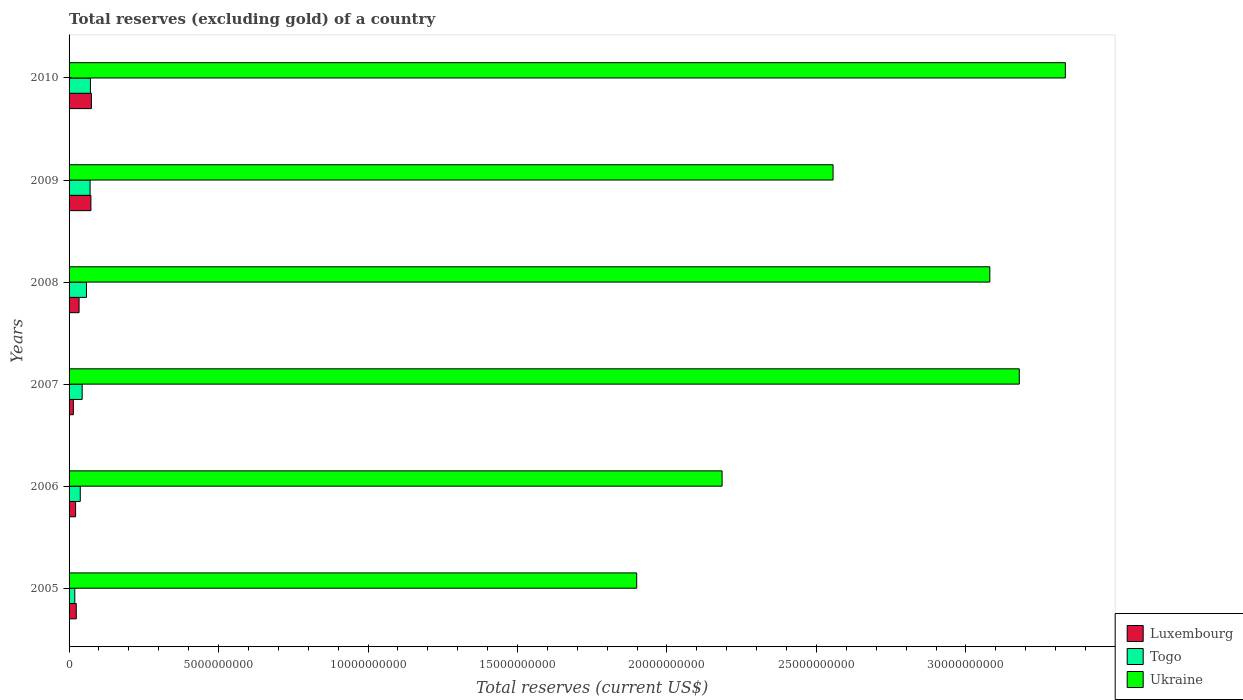How many groups of bars are there?
Ensure brevity in your answer.  6. Are the number of bars per tick equal to the number of legend labels?
Provide a short and direct response. Yes. Are the number of bars on each tick of the Y-axis equal?
Give a very brief answer. Yes. How many bars are there on the 3rd tick from the bottom?
Provide a short and direct response. 3. What is the total reserves (excluding gold) in Togo in 2007?
Offer a very short reply. 4.38e+08. Across all years, what is the maximum total reserves (excluding gold) in Luxembourg?
Give a very brief answer. 7.47e+08. Across all years, what is the minimum total reserves (excluding gold) in Luxembourg?
Keep it short and to the point. 1.44e+08. What is the total total reserves (excluding gold) in Ukraine in the graph?
Your answer should be very brief. 1.62e+11. What is the difference between the total reserves (excluding gold) in Ukraine in 2005 and that in 2010?
Ensure brevity in your answer.  -1.43e+1. What is the difference between the total reserves (excluding gold) in Ukraine in 2009 and the total reserves (excluding gold) in Luxembourg in 2007?
Keep it short and to the point. 2.54e+1. What is the average total reserves (excluding gold) in Ukraine per year?
Your response must be concise. 2.71e+1. In the year 2009, what is the difference between the total reserves (excluding gold) in Luxembourg and total reserves (excluding gold) in Togo?
Keep it short and to the point. 2.74e+07. What is the ratio of the total reserves (excluding gold) in Togo in 2005 to that in 2007?
Provide a succinct answer. 0.44. What is the difference between the highest and the second highest total reserves (excluding gold) in Ukraine?
Your response must be concise. 1.54e+09. What is the difference between the highest and the lowest total reserves (excluding gold) in Ukraine?
Keep it short and to the point. 1.43e+1. In how many years, is the total reserves (excluding gold) in Togo greater than the average total reserves (excluding gold) in Togo taken over all years?
Offer a very short reply. 3. Is the sum of the total reserves (excluding gold) in Togo in 2008 and 2009 greater than the maximum total reserves (excluding gold) in Luxembourg across all years?
Ensure brevity in your answer.  Yes. What does the 2nd bar from the top in 2010 represents?
Provide a short and direct response. Togo. What does the 3rd bar from the bottom in 2009 represents?
Make the answer very short. Ukraine. How many bars are there?
Make the answer very short. 18. What is the difference between two consecutive major ticks on the X-axis?
Provide a short and direct response. 5.00e+09. Are the values on the major ticks of X-axis written in scientific E-notation?
Your response must be concise. No. Does the graph contain any zero values?
Provide a short and direct response. No. How are the legend labels stacked?
Give a very brief answer. Vertical. What is the title of the graph?
Your answer should be compact. Total reserves (excluding gold) of a country. What is the label or title of the X-axis?
Provide a succinct answer. Total reserves (current US$). What is the Total reserves (current US$) of Luxembourg in 2005?
Keep it short and to the point. 2.41e+08. What is the Total reserves (current US$) of Togo in 2005?
Keep it short and to the point. 1.92e+08. What is the Total reserves (current US$) in Ukraine in 2005?
Ensure brevity in your answer.  1.90e+1. What is the Total reserves (current US$) in Luxembourg in 2006?
Keep it short and to the point. 2.18e+08. What is the Total reserves (current US$) of Togo in 2006?
Ensure brevity in your answer.  3.75e+08. What is the Total reserves (current US$) of Ukraine in 2006?
Give a very brief answer. 2.18e+1. What is the Total reserves (current US$) of Luxembourg in 2007?
Provide a succinct answer. 1.44e+08. What is the Total reserves (current US$) of Togo in 2007?
Your answer should be very brief. 4.38e+08. What is the Total reserves (current US$) in Ukraine in 2007?
Make the answer very short. 3.18e+1. What is the Total reserves (current US$) in Luxembourg in 2008?
Your answer should be compact. 3.35e+08. What is the Total reserves (current US$) of Togo in 2008?
Your response must be concise. 5.82e+08. What is the Total reserves (current US$) of Ukraine in 2008?
Keep it short and to the point. 3.08e+1. What is the Total reserves (current US$) of Luxembourg in 2009?
Give a very brief answer. 7.31e+08. What is the Total reserves (current US$) in Togo in 2009?
Offer a very short reply. 7.03e+08. What is the Total reserves (current US$) of Ukraine in 2009?
Ensure brevity in your answer.  2.56e+1. What is the Total reserves (current US$) of Luxembourg in 2010?
Your answer should be compact. 7.47e+08. What is the Total reserves (current US$) of Togo in 2010?
Ensure brevity in your answer.  7.15e+08. What is the Total reserves (current US$) of Ukraine in 2010?
Give a very brief answer. 3.33e+1. Across all years, what is the maximum Total reserves (current US$) of Luxembourg?
Provide a short and direct response. 7.47e+08. Across all years, what is the maximum Total reserves (current US$) of Togo?
Your answer should be very brief. 7.15e+08. Across all years, what is the maximum Total reserves (current US$) of Ukraine?
Keep it short and to the point. 3.33e+1. Across all years, what is the minimum Total reserves (current US$) of Luxembourg?
Your answer should be very brief. 1.44e+08. Across all years, what is the minimum Total reserves (current US$) in Togo?
Make the answer very short. 1.92e+08. Across all years, what is the minimum Total reserves (current US$) of Ukraine?
Provide a succinct answer. 1.90e+1. What is the total Total reserves (current US$) of Luxembourg in the graph?
Offer a terse response. 2.41e+09. What is the total Total reserves (current US$) in Togo in the graph?
Ensure brevity in your answer.  3.00e+09. What is the total Total reserves (current US$) in Ukraine in the graph?
Ensure brevity in your answer.  1.62e+11. What is the difference between the Total reserves (current US$) of Luxembourg in 2005 and that in 2006?
Ensure brevity in your answer.  2.30e+07. What is the difference between the Total reserves (current US$) of Togo in 2005 and that in 2006?
Your answer should be compact. -1.83e+08. What is the difference between the Total reserves (current US$) in Ukraine in 2005 and that in 2006?
Offer a terse response. -2.86e+09. What is the difference between the Total reserves (current US$) of Luxembourg in 2005 and that in 2007?
Your answer should be compact. 9.75e+07. What is the difference between the Total reserves (current US$) of Togo in 2005 and that in 2007?
Offer a very short reply. -2.47e+08. What is the difference between the Total reserves (current US$) in Ukraine in 2005 and that in 2007?
Give a very brief answer. -1.28e+1. What is the difference between the Total reserves (current US$) in Luxembourg in 2005 and that in 2008?
Make the answer very short. -9.35e+07. What is the difference between the Total reserves (current US$) of Togo in 2005 and that in 2008?
Your answer should be very brief. -3.90e+08. What is the difference between the Total reserves (current US$) of Ukraine in 2005 and that in 2008?
Provide a short and direct response. -1.18e+1. What is the difference between the Total reserves (current US$) in Luxembourg in 2005 and that in 2009?
Offer a very short reply. -4.89e+08. What is the difference between the Total reserves (current US$) in Togo in 2005 and that in 2009?
Keep it short and to the point. -5.12e+08. What is the difference between the Total reserves (current US$) of Ukraine in 2005 and that in 2009?
Keep it short and to the point. -6.57e+09. What is the difference between the Total reserves (current US$) in Luxembourg in 2005 and that in 2010?
Provide a short and direct response. -5.06e+08. What is the difference between the Total reserves (current US$) in Togo in 2005 and that in 2010?
Your answer should be very brief. -5.23e+08. What is the difference between the Total reserves (current US$) in Ukraine in 2005 and that in 2010?
Offer a terse response. -1.43e+1. What is the difference between the Total reserves (current US$) of Luxembourg in 2006 and that in 2007?
Your answer should be compact. 7.45e+07. What is the difference between the Total reserves (current US$) in Togo in 2006 and that in 2007?
Make the answer very short. -6.36e+07. What is the difference between the Total reserves (current US$) in Ukraine in 2006 and that in 2007?
Provide a short and direct response. -9.94e+09. What is the difference between the Total reserves (current US$) of Luxembourg in 2006 and that in 2008?
Offer a terse response. -1.17e+08. What is the difference between the Total reserves (current US$) in Togo in 2006 and that in 2008?
Offer a very short reply. -2.07e+08. What is the difference between the Total reserves (current US$) in Ukraine in 2006 and that in 2008?
Your response must be concise. -8.96e+09. What is the difference between the Total reserves (current US$) in Luxembourg in 2006 and that in 2009?
Give a very brief answer. -5.12e+08. What is the difference between the Total reserves (current US$) of Togo in 2006 and that in 2009?
Keep it short and to the point. -3.29e+08. What is the difference between the Total reserves (current US$) in Ukraine in 2006 and that in 2009?
Give a very brief answer. -3.71e+09. What is the difference between the Total reserves (current US$) in Luxembourg in 2006 and that in 2010?
Your response must be concise. -5.29e+08. What is the difference between the Total reserves (current US$) in Togo in 2006 and that in 2010?
Your response must be concise. -3.40e+08. What is the difference between the Total reserves (current US$) of Ukraine in 2006 and that in 2010?
Your answer should be very brief. -1.15e+1. What is the difference between the Total reserves (current US$) of Luxembourg in 2007 and that in 2008?
Your response must be concise. -1.91e+08. What is the difference between the Total reserves (current US$) in Togo in 2007 and that in 2008?
Provide a succinct answer. -1.44e+08. What is the difference between the Total reserves (current US$) in Ukraine in 2007 and that in 2008?
Give a very brief answer. 9.85e+08. What is the difference between the Total reserves (current US$) in Luxembourg in 2007 and that in 2009?
Ensure brevity in your answer.  -5.87e+08. What is the difference between the Total reserves (current US$) of Togo in 2007 and that in 2009?
Provide a succinct answer. -2.65e+08. What is the difference between the Total reserves (current US$) of Ukraine in 2007 and that in 2009?
Give a very brief answer. 6.23e+09. What is the difference between the Total reserves (current US$) of Luxembourg in 2007 and that in 2010?
Offer a terse response. -6.04e+08. What is the difference between the Total reserves (current US$) in Togo in 2007 and that in 2010?
Provide a short and direct response. -2.77e+08. What is the difference between the Total reserves (current US$) in Ukraine in 2007 and that in 2010?
Provide a succinct answer. -1.54e+09. What is the difference between the Total reserves (current US$) in Luxembourg in 2008 and that in 2009?
Provide a succinct answer. -3.96e+08. What is the difference between the Total reserves (current US$) in Togo in 2008 and that in 2009?
Offer a very short reply. -1.21e+08. What is the difference between the Total reserves (current US$) in Ukraine in 2008 and that in 2009?
Offer a terse response. 5.24e+09. What is the difference between the Total reserves (current US$) in Luxembourg in 2008 and that in 2010?
Make the answer very short. -4.12e+08. What is the difference between the Total reserves (current US$) in Togo in 2008 and that in 2010?
Give a very brief answer. -1.33e+08. What is the difference between the Total reserves (current US$) of Ukraine in 2008 and that in 2010?
Provide a short and direct response. -2.53e+09. What is the difference between the Total reserves (current US$) in Luxembourg in 2009 and that in 2010?
Offer a terse response. -1.66e+07. What is the difference between the Total reserves (current US$) of Togo in 2009 and that in 2010?
Your answer should be compact. -1.18e+07. What is the difference between the Total reserves (current US$) in Ukraine in 2009 and that in 2010?
Provide a short and direct response. -7.77e+09. What is the difference between the Total reserves (current US$) in Luxembourg in 2005 and the Total reserves (current US$) in Togo in 2006?
Give a very brief answer. -1.33e+08. What is the difference between the Total reserves (current US$) in Luxembourg in 2005 and the Total reserves (current US$) in Ukraine in 2006?
Your answer should be compact. -2.16e+1. What is the difference between the Total reserves (current US$) in Togo in 2005 and the Total reserves (current US$) in Ukraine in 2006?
Keep it short and to the point. -2.17e+1. What is the difference between the Total reserves (current US$) in Luxembourg in 2005 and the Total reserves (current US$) in Togo in 2007?
Provide a short and direct response. -1.97e+08. What is the difference between the Total reserves (current US$) of Luxembourg in 2005 and the Total reserves (current US$) of Ukraine in 2007?
Your answer should be very brief. -3.15e+1. What is the difference between the Total reserves (current US$) of Togo in 2005 and the Total reserves (current US$) of Ukraine in 2007?
Provide a short and direct response. -3.16e+1. What is the difference between the Total reserves (current US$) of Luxembourg in 2005 and the Total reserves (current US$) of Togo in 2008?
Provide a short and direct response. -3.41e+08. What is the difference between the Total reserves (current US$) in Luxembourg in 2005 and the Total reserves (current US$) in Ukraine in 2008?
Your answer should be compact. -3.06e+1. What is the difference between the Total reserves (current US$) in Togo in 2005 and the Total reserves (current US$) in Ukraine in 2008?
Give a very brief answer. -3.06e+1. What is the difference between the Total reserves (current US$) of Luxembourg in 2005 and the Total reserves (current US$) of Togo in 2009?
Provide a succinct answer. -4.62e+08. What is the difference between the Total reserves (current US$) of Luxembourg in 2005 and the Total reserves (current US$) of Ukraine in 2009?
Give a very brief answer. -2.53e+1. What is the difference between the Total reserves (current US$) in Togo in 2005 and the Total reserves (current US$) in Ukraine in 2009?
Offer a terse response. -2.54e+1. What is the difference between the Total reserves (current US$) in Luxembourg in 2005 and the Total reserves (current US$) in Togo in 2010?
Provide a short and direct response. -4.74e+08. What is the difference between the Total reserves (current US$) in Luxembourg in 2005 and the Total reserves (current US$) in Ukraine in 2010?
Make the answer very short. -3.31e+1. What is the difference between the Total reserves (current US$) in Togo in 2005 and the Total reserves (current US$) in Ukraine in 2010?
Give a very brief answer. -3.31e+1. What is the difference between the Total reserves (current US$) in Luxembourg in 2006 and the Total reserves (current US$) in Togo in 2007?
Give a very brief answer. -2.20e+08. What is the difference between the Total reserves (current US$) in Luxembourg in 2006 and the Total reserves (current US$) in Ukraine in 2007?
Your response must be concise. -3.16e+1. What is the difference between the Total reserves (current US$) in Togo in 2006 and the Total reserves (current US$) in Ukraine in 2007?
Provide a succinct answer. -3.14e+1. What is the difference between the Total reserves (current US$) in Luxembourg in 2006 and the Total reserves (current US$) in Togo in 2008?
Offer a terse response. -3.64e+08. What is the difference between the Total reserves (current US$) in Luxembourg in 2006 and the Total reserves (current US$) in Ukraine in 2008?
Ensure brevity in your answer.  -3.06e+1. What is the difference between the Total reserves (current US$) in Togo in 2006 and the Total reserves (current US$) in Ukraine in 2008?
Your response must be concise. -3.04e+1. What is the difference between the Total reserves (current US$) of Luxembourg in 2006 and the Total reserves (current US$) of Togo in 2009?
Keep it short and to the point. -4.85e+08. What is the difference between the Total reserves (current US$) of Luxembourg in 2006 and the Total reserves (current US$) of Ukraine in 2009?
Offer a very short reply. -2.53e+1. What is the difference between the Total reserves (current US$) in Togo in 2006 and the Total reserves (current US$) in Ukraine in 2009?
Ensure brevity in your answer.  -2.52e+1. What is the difference between the Total reserves (current US$) in Luxembourg in 2006 and the Total reserves (current US$) in Togo in 2010?
Provide a succinct answer. -4.97e+08. What is the difference between the Total reserves (current US$) of Luxembourg in 2006 and the Total reserves (current US$) of Ukraine in 2010?
Provide a succinct answer. -3.31e+1. What is the difference between the Total reserves (current US$) of Togo in 2006 and the Total reserves (current US$) of Ukraine in 2010?
Your response must be concise. -3.30e+1. What is the difference between the Total reserves (current US$) of Luxembourg in 2007 and the Total reserves (current US$) of Togo in 2008?
Offer a very short reply. -4.38e+08. What is the difference between the Total reserves (current US$) in Luxembourg in 2007 and the Total reserves (current US$) in Ukraine in 2008?
Your answer should be very brief. -3.07e+1. What is the difference between the Total reserves (current US$) of Togo in 2007 and the Total reserves (current US$) of Ukraine in 2008?
Offer a terse response. -3.04e+1. What is the difference between the Total reserves (current US$) in Luxembourg in 2007 and the Total reserves (current US$) in Togo in 2009?
Give a very brief answer. -5.60e+08. What is the difference between the Total reserves (current US$) in Luxembourg in 2007 and the Total reserves (current US$) in Ukraine in 2009?
Your answer should be very brief. -2.54e+1. What is the difference between the Total reserves (current US$) in Togo in 2007 and the Total reserves (current US$) in Ukraine in 2009?
Your response must be concise. -2.51e+1. What is the difference between the Total reserves (current US$) of Luxembourg in 2007 and the Total reserves (current US$) of Togo in 2010?
Keep it short and to the point. -5.71e+08. What is the difference between the Total reserves (current US$) in Luxembourg in 2007 and the Total reserves (current US$) in Ukraine in 2010?
Your answer should be compact. -3.32e+1. What is the difference between the Total reserves (current US$) of Togo in 2007 and the Total reserves (current US$) of Ukraine in 2010?
Offer a terse response. -3.29e+1. What is the difference between the Total reserves (current US$) in Luxembourg in 2008 and the Total reserves (current US$) in Togo in 2009?
Provide a succinct answer. -3.69e+08. What is the difference between the Total reserves (current US$) in Luxembourg in 2008 and the Total reserves (current US$) in Ukraine in 2009?
Offer a very short reply. -2.52e+1. What is the difference between the Total reserves (current US$) in Togo in 2008 and the Total reserves (current US$) in Ukraine in 2009?
Provide a succinct answer. -2.50e+1. What is the difference between the Total reserves (current US$) of Luxembourg in 2008 and the Total reserves (current US$) of Togo in 2010?
Offer a very short reply. -3.80e+08. What is the difference between the Total reserves (current US$) in Luxembourg in 2008 and the Total reserves (current US$) in Ukraine in 2010?
Your response must be concise. -3.30e+1. What is the difference between the Total reserves (current US$) of Togo in 2008 and the Total reserves (current US$) of Ukraine in 2010?
Offer a terse response. -3.27e+1. What is the difference between the Total reserves (current US$) of Luxembourg in 2009 and the Total reserves (current US$) of Togo in 2010?
Give a very brief answer. 1.56e+07. What is the difference between the Total reserves (current US$) of Luxembourg in 2009 and the Total reserves (current US$) of Ukraine in 2010?
Offer a very short reply. -3.26e+1. What is the difference between the Total reserves (current US$) of Togo in 2009 and the Total reserves (current US$) of Ukraine in 2010?
Your answer should be very brief. -3.26e+1. What is the average Total reserves (current US$) in Luxembourg per year?
Your response must be concise. 4.02e+08. What is the average Total reserves (current US$) in Togo per year?
Keep it short and to the point. 5.01e+08. What is the average Total reserves (current US$) of Ukraine per year?
Give a very brief answer. 2.71e+1. In the year 2005, what is the difference between the Total reserves (current US$) of Luxembourg and Total reserves (current US$) of Togo?
Ensure brevity in your answer.  4.96e+07. In the year 2005, what is the difference between the Total reserves (current US$) of Luxembourg and Total reserves (current US$) of Ukraine?
Your answer should be very brief. -1.87e+1. In the year 2005, what is the difference between the Total reserves (current US$) in Togo and Total reserves (current US$) in Ukraine?
Give a very brief answer. -1.88e+1. In the year 2006, what is the difference between the Total reserves (current US$) in Luxembourg and Total reserves (current US$) in Togo?
Keep it short and to the point. -1.56e+08. In the year 2006, what is the difference between the Total reserves (current US$) of Luxembourg and Total reserves (current US$) of Ukraine?
Offer a terse response. -2.16e+1. In the year 2006, what is the difference between the Total reserves (current US$) in Togo and Total reserves (current US$) in Ukraine?
Offer a terse response. -2.15e+1. In the year 2007, what is the difference between the Total reserves (current US$) in Luxembourg and Total reserves (current US$) in Togo?
Offer a very short reply. -2.95e+08. In the year 2007, what is the difference between the Total reserves (current US$) in Luxembourg and Total reserves (current US$) in Ukraine?
Offer a terse response. -3.16e+1. In the year 2007, what is the difference between the Total reserves (current US$) in Togo and Total reserves (current US$) in Ukraine?
Ensure brevity in your answer.  -3.13e+1. In the year 2008, what is the difference between the Total reserves (current US$) in Luxembourg and Total reserves (current US$) in Togo?
Your answer should be compact. -2.47e+08. In the year 2008, what is the difference between the Total reserves (current US$) in Luxembourg and Total reserves (current US$) in Ukraine?
Your answer should be very brief. -3.05e+1. In the year 2008, what is the difference between the Total reserves (current US$) of Togo and Total reserves (current US$) of Ukraine?
Provide a succinct answer. -3.02e+1. In the year 2009, what is the difference between the Total reserves (current US$) of Luxembourg and Total reserves (current US$) of Togo?
Make the answer very short. 2.74e+07. In the year 2009, what is the difference between the Total reserves (current US$) of Luxembourg and Total reserves (current US$) of Ukraine?
Your answer should be very brief. -2.48e+1. In the year 2009, what is the difference between the Total reserves (current US$) of Togo and Total reserves (current US$) of Ukraine?
Provide a short and direct response. -2.49e+1. In the year 2010, what is the difference between the Total reserves (current US$) in Luxembourg and Total reserves (current US$) in Togo?
Ensure brevity in your answer.  3.22e+07. In the year 2010, what is the difference between the Total reserves (current US$) in Luxembourg and Total reserves (current US$) in Ukraine?
Offer a terse response. -3.26e+1. In the year 2010, what is the difference between the Total reserves (current US$) in Togo and Total reserves (current US$) in Ukraine?
Keep it short and to the point. -3.26e+1. What is the ratio of the Total reserves (current US$) of Luxembourg in 2005 to that in 2006?
Offer a terse response. 1.11. What is the ratio of the Total reserves (current US$) in Togo in 2005 to that in 2006?
Give a very brief answer. 0.51. What is the ratio of the Total reserves (current US$) in Ukraine in 2005 to that in 2006?
Keep it short and to the point. 0.87. What is the ratio of the Total reserves (current US$) in Luxembourg in 2005 to that in 2007?
Give a very brief answer. 1.68. What is the ratio of the Total reserves (current US$) of Togo in 2005 to that in 2007?
Make the answer very short. 0.44. What is the ratio of the Total reserves (current US$) in Ukraine in 2005 to that in 2007?
Make the answer very short. 0.6. What is the ratio of the Total reserves (current US$) in Luxembourg in 2005 to that in 2008?
Provide a succinct answer. 0.72. What is the ratio of the Total reserves (current US$) in Togo in 2005 to that in 2008?
Ensure brevity in your answer.  0.33. What is the ratio of the Total reserves (current US$) of Ukraine in 2005 to that in 2008?
Offer a very short reply. 0.62. What is the ratio of the Total reserves (current US$) of Luxembourg in 2005 to that in 2009?
Provide a short and direct response. 0.33. What is the ratio of the Total reserves (current US$) of Togo in 2005 to that in 2009?
Keep it short and to the point. 0.27. What is the ratio of the Total reserves (current US$) of Ukraine in 2005 to that in 2009?
Your answer should be very brief. 0.74. What is the ratio of the Total reserves (current US$) in Luxembourg in 2005 to that in 2010?
Ensure brevity in your answer.  0.32. What is the ratio of the Total reserves (current US$) of Togo in 2005 to that in 2010?
Offer a terse response. 0.27. What is the ratio of the Total reserves (current US$) in Ukraine in 2005 to that in 2010?
Provide a short and direct response. 0.57. What is the ratio of the Total reserves (current US$) of Luxembourg in 2006 to that in 2007?
Keep it short and to the point. 1.52. What is the ratio of the Total reserves (current US$) of Togo in 2006 to that in 2007?
Provide a succinct answer. 0.85. What is the ratio of the Total reserves (current US$) of Ukraine in 2006 to that in 2007?
Keep it short and to the point. 0.69. What is the ratio of the Total reserves (current US$) of Luxembourg in 2006 to that in 2008?
Your response must be concise. 0.65. What is the ratio of the Total reserves (current US$) of Togo in 2006 to that in 2008?
Provide a short and direct response. 0.64. What is the ratio of the Total reserves (current US$) in Ukraine in 2006 to that in 2008?
Your response must be concise. 0.71. What is the ratio of the Total reserves (current US$) of Luxembourg in 2006 to that in 2009?
Provide a succinct answer. 0.3. What is the ratio of the Total reserves (current US$) of Togo in 2006 to that in 2009?
Ensure brevity in your answer.  0.53. What is the ratio of the Total reserves (current US$) in Ukraine in 2006 to that in 2009?
Offer a terse response. 0.85. What is the ratio of the Total reserves (current US$) in Luxembourg in 2006 to that in 2010?
Provide a short and direct response. 0.29. What is the ratio of the Total reserves (current US$) in Togo in 2006 to that in 2010?
Your answer should be compact. 0.52. What is the ratio of the Total reserves (current US$) in Ukraine in 2006 to that in 2010?
Your answer should be very brief. 0.66. What is the ratio of the Total reserves (current US$) of Luxembourg in 2007 to that in 2008?
Keep it short and to the point. 0.43. What is the ratio of the Total reserves (current US$) of Togo in 2007 to that in 2008?
Ensure brevity in your answer.  0.75. What is the ratio of the Total reserves (current US$) in Ukraine in 2007 to that in 2008?
Your answer should be very brief. 1.03. What is the ratio of the Total reserves (current US$) in Luxembourg in 2007 to that in 2009?
Your response must be concise. 0.2. What is the ratio of the Total reserves (current US$) in Togo in 2007 to that in 2009?
Your answer should be compact. 0.62. What is the ratio of the Total reserves (current US$) in Ukraine in 2007 to that in 2009?
Offer a very short reply. 1.24. What is the ratio of the Total reserves (current US$) in Luxembourg in 2007 to that in 2010?
Give a very brief answer. 0.19. What is the ratio of the Total reserves (current US$) of Togo in 2007 to that in 2010?
Offer a very short reply. 0.61. What is the ratio of the Total reserves (current US$) in Ukraine in 2007 to that in 2010?
Keep it short and to the point. 0.95. What is the ratio of the Total reserves (current US$) in Luxembourg in 2008 to that in 2009?
Offer a very short reply. 0.46. What is the ratio of the Total reserves (current US$) of Togo in 2008 to that in 2009?
Offer a very short reply. 0.83. What is the ratio of the Total reserves (current US$) in Ukraine in 2008 to that in 2009?
Offer a very short reply. 1.21. What is the ratio of the Total reserves (current US$) in Luxembourg in 2008 to that in 2010?
Keep it short and to the point. 0.45. What is the ratio of the Total reserves (current US$) of Togo in 2008 to that in 2010?
Your response must be concise. 0.81. What is the ratio of the Total reserves (current US$) in Ukraine in 2008 to that in 2010?
Your answer should be compact. 0.92. What is the ratio of the Total reserves (current US$) in Luxembourg in 2009 to that in 2010?
Make the answer very short. 0.98. What is the ratio of the Total reserves (current US$) of Togo in 2009 to that in 2010?
Your answer should be compact. 0.98. What is the ratio of the Total reserves (current US$) in Ukraine in 2009 to that in 2010?
Keep it short and to the point. 0.77. What is the difference between the highest and the second highest Total reserves (current US$) of Luxembourg?
Provide a succinct answer. 1.66e+07. What is the difference between the highest and the second highest Total reserves (current US$) of Togo?
Provide a succinct answer. 1.18e+07. What is the difference between the highest and the second highest Total reserves (current US$) of Ukraine?
Offer a terse response. 1.54e+09. What is the difference between the highest and the lowest Total reserves (current US$) in Luxembourg?
Your response must be concise. 6.04e+08. What is the difference between the highest and the lowest Total reserves (current US$) of Togo?
Make the answer very short. 5.23e+08. What is the difference between the highest and the lowest Total reserves (current US$) of Ukraine?
Give a very brief answer. 1.43e+1. 